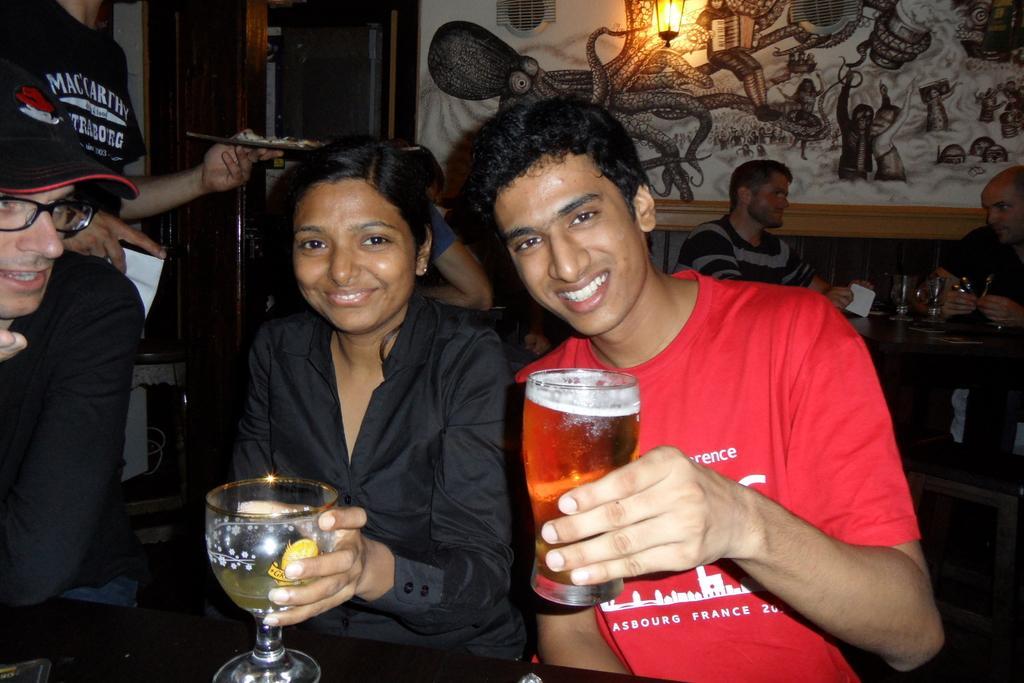Could you give a brief overview of what you see in this image? In this image there are two persons who are holding the glasses in which there is some drink. In the background there are two persons sitting around the table. On the table there are glasses. At the top there is a wall on which there is a painting and a light. On the left side there is a man sitting in the chair. Behind him there is another man who is holding the paper and a plate. In the background there is a door. 